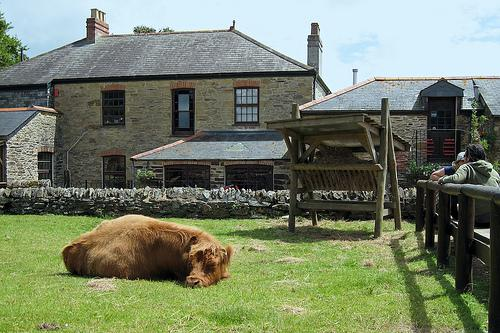Question: how does the cow look?
Choices:
A. Hungry.
B. Sad.
C. Happy.
D. Tired.
Answer with the letter. Answer: D 